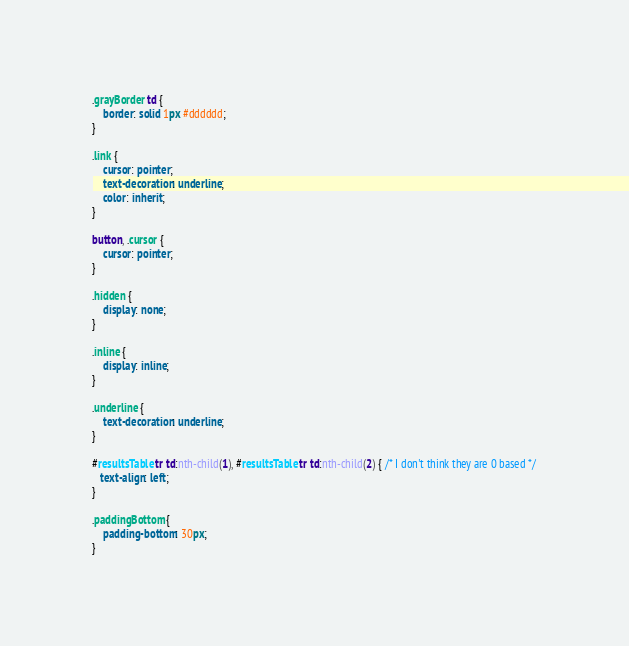<code> <loc_0><loc_0><loc_500><loc_500><_CSS_>.grayBorder td {
    border: solid 1px #dddddd;
}

.link {
    cursor: pointer;
    text-decoration: underline;
    color: inherit;
}

button, .cursor {
    cursor: pointer;
}

.hidden {
    display: none;
}

.inline {
    display: inline;
}

.underline {
    text-decoration: underline;
}

#resultsTable tr td:nth-child(1), #resultsTable tr td:nth-child(2) { /* I don't think they are 0 based */
   text-align: left;
}

.paddingBottom {
    padding-bottom: 30px;
}
</code> 